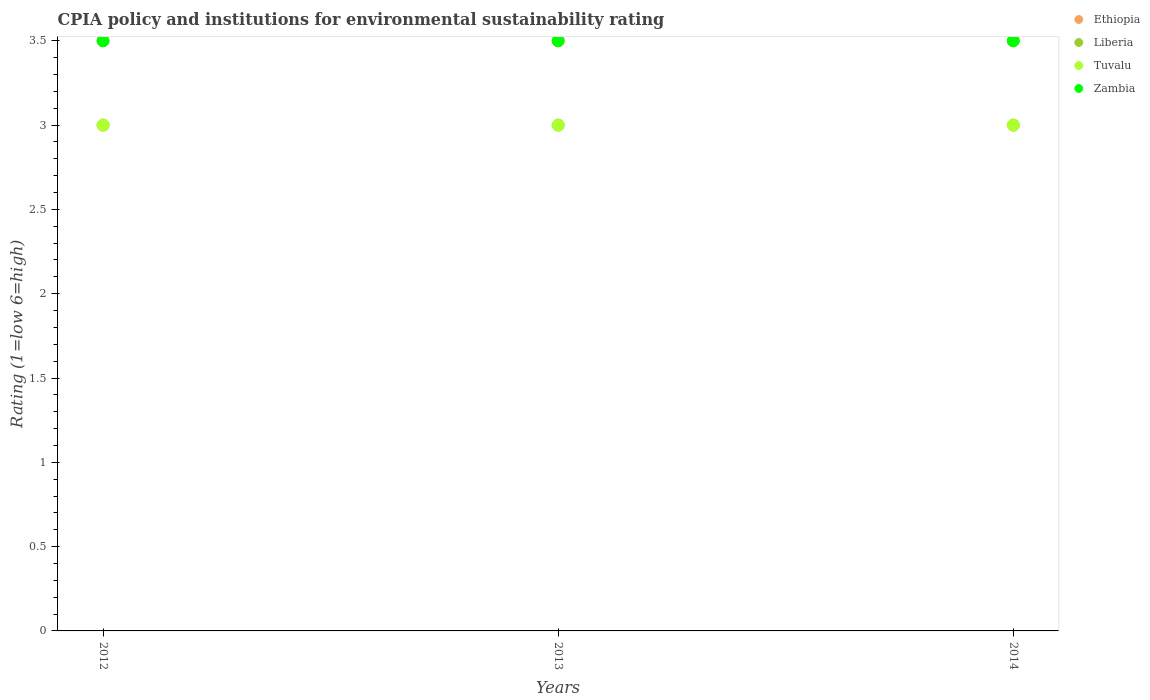Is the number of dotlines equal to the number of legend labels?
Your answer should be compact. Yes. What is the CPIA rating in Tuvalu in 2014?
Your response must be concise. 3. Across all years, what is the maximum CPIA rating in Tuvalu?
Make the answer very short. 3. What is the difference between the CPIA rating in Zambia in 2014 and the CPIA rating in Ethiopia in 2012?
Give a very brief answer. 0. What is the average CPIA rating in Liberia per year?
Offer a terse response. 3. In how many years, is the CPIA rating in Zambia greater than 3?
Provide a short and direct response. 3. Is the difference between the CPIA rating in Liberia in 2012 and 2013 greater than the difference between the CPIA rating in Zambia in 2012 and 2013?
Offer a terse response. No. What is the difference between the highest and the second highest CPIA rating in Liberia?
Your answer should be very brief. 0. What is the difference between the highest and the lowest CPIA rating in Ethiopia?
Offer a terse response. 0. Is the sum of the CPIA rating in Tuvalu in 2012 and 2014 greater than the maximum CPIA rating in Liberia across all years?
Offer a very short reply. Yes. Does the CPIA rating in Tuvalu monotonically increase over the years?
Provide a succinct answer. No. Is the CPIA rating in Zambia strictly greater than the CPIA rating in Liberia over the years?
Keep it short and to the point. Yes. Is the CPIA rating in Liberia strictly less than the CPIA rating in Ethiopia over the years?
Your response must be concise. Yes. What is the difference between two consecutive major ticks on the Y-axis?
Your response must be concise. 0.5. Are the values on the major ticks of Y-axis written in scientific E-notation?
Offer a terse response. No. Does the graph contain any zero values?
Your answer should be compact. No. Does the graph contain grids?
Your answer should be very brief. No. How many legend labels are there?
Keep it short and to the point. 4. How are the legend labels stacked?
Your response must be concise. Vertical. What is the title of the graph?
Offer a very short reply. CPIA policy and institutions for environmental sustainability rating. What is the label or title of the Y-axis?
Offer a terse response. Rating (1=low 6=high). What is the Rating (1=low 6=high) in Liberia in 2012?
Ensure brevity in your answer.  3. What is the Rating (1=low 6=high) of Tuvalu in 2012?
Your answer should be compact. 3. What is the Rating (1=low 6=high) in Zambia in 2012?
Provide a short and direct response. 3.5. What is the Rating (1=low 6=high) of Ethiopia in 2013?
Make the answer very short. 3.5. What is the Rating (1=low 6=high) of Liberia in 2013?
Provide a succinct answer. 3. What is the Rating (1=low 6=high) in Zambia in 2013?
Your response must be concise. 3.5. What is the Rating (1=low 6=high) in Liberia in 2014?
Make the answer very short. 3. Across all years, what is the maximum Rating (1=low 6=high) of Liberia?
Offer a terse response. 3. Across all years, what is the maximum Rating (1=low 6=high) of Tuvalu?
Provide a short and direct response. 3. Across all years, what is the minimum Rating (1=low 6=high) of Tuvalu?
Your response must be concise. 3. What is the total Rating (1=low 6=high) in Ethiopia in the graph?
Make the answer very short. 10.5. What is the total Rating (1=low 6=high) in Tuvalu in the graph?
Provide a succinct answer. 9. What is the difference between the Rating (1=low 6=high) in Ethiopia in 2012 and that in 2013?
Ensure brevity in your answer.  0. What is the difference between the Rating (1=low 6=high) of Zambia in 2012 and that in 2013?
Provide a succinct answer. 0. What is the difference between the Rating (1=low 6=high) in Ethiopia in 2012 and that in 2014?
Make the answer very short. 0. What is the difference between the Rating (1=low 6=high) of Zambia in 2012 and that in 2014?
Keep it short and to the point. 0. What is the difference between the Rating (1=low 6=high) of Ethiopia in 2013 and that in 2014?
Make the answer very short. 0. What is the difference between the Rating (1=low 6=high) in Tuvalu in 2013 and that in 2014?
Keep it short and to the point. 0. What is the difference between the Rating (1=low 6=high) in Zambia in 2013 and that in 2014?
Your answer should be compact. 0. What is the difference between the Rating (1=low 6=high) of Ethiopia in 2012 and the Rating (1=low 6=high) of Liberia in 2013?
Provide a short and direct response. 0.5. What is the difference between the Rating (1=low 6=high) of Ethiopia in 2012 and the Rating (1=low 6=high) of Tuvalu in 2013?
Make the answer very short. 0.5. What is the difference between the Rating (1=low 6=high) in Ethiopia in 2012 and the Rating (1=low 6=high) in Zambia in 2013?
Your answer should be very brief. 0. What is the difference between the Rating (1=low 6=high) in Liberia in 2012 and the Rating (1=low 6=high) in Zambia in 2013?
Your answer should be compact. -0.5. What is the difference between the Rating (1=low 6=high) in Tuvalu in 2012 and the Rating (1=low 6=high) in Zambia in 2013?
Provide a short and direct response. -0.5. What is the difference between the Rating (1=low 6=high) in Ethiopia in 2012 and the Rating (1=low 6=high) in Liberia in 2014?
Make the answer very short. 0.5. What is the difference between the Rating (1=low 6=high) of Liberia in 2012 and the Rating (1=low 6=high) of Tuvalu in 2014?
Provide a short and direct response. 0. What is the difference between the Rating (1=low 6=high) of Liberia in 2012 and the Rating (1=low 6=high) of Zambia in 2014?
Give a very brief answer. -0.5. What is the difference between the Rating (1=low 6=high) in Ethiopia in 2013 and the Rating (1=low 6=high) in Liberia in 2014?
Provide a succinct answer. 0.5. What is the difference between the Rating (1=low 6=high) in Liberia in 2013 and the Rating (1=low 6=high) in Zambia in 2014?
Provide a short and direct response. -0.5. What is the average Rating (1=low 6=high) of Liberia per year?
Your answer should be very brief. 3. What is the average Rating (1=low 6=high) of Tuvalu per year?
Offer a very short reply. 3. In the year 2012, what is the difference between the Rating (1=low 6=high) of Ethiopia and Rating (1=low 6=high) of Tuvalu?
Provide a succinct answer. 0.5. In the year 2012, what is the difference between the Rating (1=low 6=high) in Ethiopia and Rating (1=low 6=high) in Zambia?
Your answer should be very brief. 0. In the year 2012, what is the difference between the Rating (1=low 6=high) of Liberia and Rating (1=low 6=high) of Tuvalu?
Offer a terse response. 0. In the year 2012, what is the difference between the Rating (1=low 6=high) in Liberia and Rating (1=low 6=high) in Zambia?
Your answer should be compact. -0.5. In the year 2013, what is the difference between the Rating (1=low 6=high) in Ethiopia and Rating (1=low 6=high) in Liberia?
Offer a terse response. 0.5. In the year 2013, what is the difference between the Rating (1=low 6=high) of Liberia and Rating (1=low 6=high) of Tuvalu?
Keep it short and to the point. 0. In the year 2013, what is the difference between the Rating (1=low 6=high) of Liberia and Rating (1=low 6=high) of Zambia?
Keep it short and to the point. -0.5. In the year 2013, what is the difference between the Rating (1=low 6=high) of Tuvalu and Rating (1=low 6=high) of Zambia?
Offer a terse response. -0.5. In the year 2014, what is the difference between the Rating (1=low 6=high) of Ethiopia and Rating (1=low 6=high) of Tuvalu?
Ensure brevity in your answer.  0.5. In the year 2014, what is the difference between the Rating (1=low 6=high) in Ethiopia and Rating (1=low 6=high) in Zambia?
Your answer should be compact. 0. In the year 2014, what is the difference between the Rating (1=low 6=high) of Liberia and Rating (1=low 6=high) of Tuvalu?
Provide a short and direct response. 0. In the year 2014, what is the difference between the Rating (1=low 6=high) of Liberia and Rating (1=low 6=high) of Zambia?
Ensure brevity in your answer.  -0.5. What is the ratio of the Rating (1=low 6=high) in Zambia in 2012 to that in 2013?
Keep it short and to the point. 1. What is the ratio of the Rating (1=low 6=high) of Ethiopia in 2012 to that in 2014?
Offer a very short reply. 1. What is the ratio of the Rating (1=low 6=high) of Zambia in 2012 to that in 2014?
Your answer should be very brief. 1. What is the ratio of the Rating (1=low 6=high) in Liberia in 2013 to that in 2014?
Your response must be concise. 1. What is the ratio of the Rating (1=low 6=high) in Tuvalu in 2013 to that in 2014?
Offer a very short reply. 1. What is the difference between the highest and the second highest Rating (1=low 6=high) of Liberia?
Give a very brief answer. 0. What is the difference between the highest and the second highest Rating (1=low 6=high) of Zambia?
Offer a terse response. 0. What is the difference between the highest and the lowest Rating (1=low 6=high) of Ethiopia?
Your response must be concise. 0. What is the difference between the highest and the lowest Rating (1=low 6=high) of Zambia?
Your response must be concise. 0. 